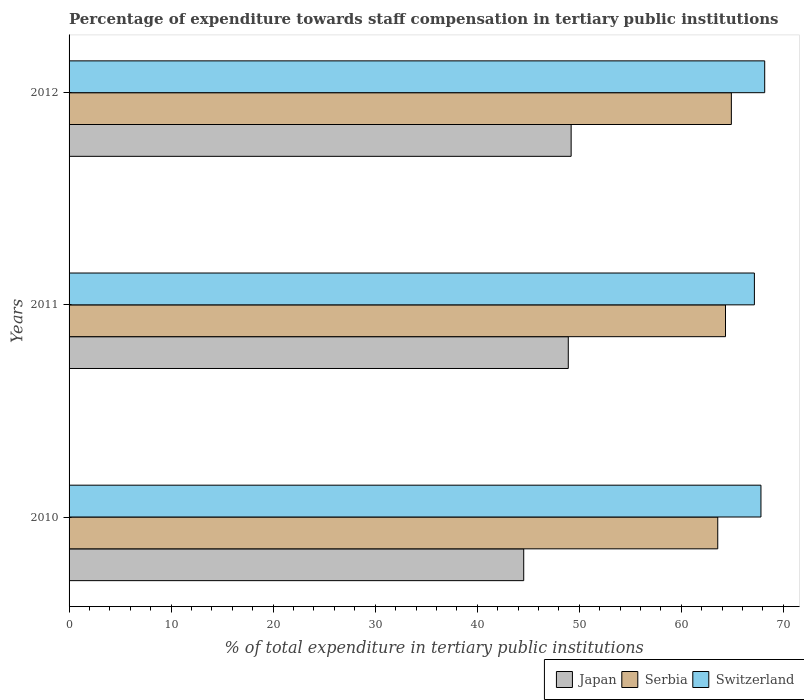Are the number of bars per tick equal to the number of legend labels?
Give a very brief answer. Yes. Are the number of bars on each tick of the Y-axis equal?
Make the answer very short. Yes. What is the percentage of expenditure towards staff compensation in Switzerland in 2012?
Ensure brevity in your answer.  68.18. Across all years, what is the maximum percentage of expenditure towards staff compensation in Serbia?
Keep it short and to the point. 64.91. Across all years, what is the minimum percentage of expenditure towards staff compensation in Switzerland?
Your answer should be compact. 67.16. In which year was the percentage of expenditure towards staff compensation in Switzerland maximum?
Give a very brief answer. 2012. What is the total percentage of expenditure towards staff compensation in Switzerland in the graph?
Give a very brief answer. 203.15. What is the difference between the percentage of expenditure towards staff compensation in Switzerland in 2010 and that in 2012?
Provide a succinct answer. -0.37. What is the difference between the percentage of expenditure towards staff compensation in Japan in 2010 and the percentage of expenditure towards staff compensation in Switzerland in 2012?
Ensure brevity in your answer.  -23.62. What is the average percentage of expenditure towards staff compensation in Serbia per year?
Offer a terse response. 64.27. In the year 2010, what is the difference between the percentage of expenditure towards staff compensation in Japan and percentage of expenditure towards staff compensation in Serbia?
Ensure brevity in your answer.  -19.02. What is the ratio of the percentage of expenditure towards staff compensation in Serbia in 2010 to that in 2011?
Give a very brief answer. 0.99. Is the difference between the percentage of expenditure towards staff compensation in Japan in 2011 and 2012 greater than the difference between the percentage of expenditure towards staff compensation in Serbia in 2011 and 2012?
Make the answer very short. Yes. What is the difference between the highest and the second highest percentage of expenditure towards staff compensation in Japan?
Make the answer very short. 0.28. What is the difference between the highest and the lowest percentage of expenditure towards staff compensation in Japan?
Provide a short and direct response. 4.65. In how many years, is the percentage of expenditure towards staff compensation in Serbia greater than the average percentage of expenditure towards staff compensation in Serbia taken over all years?
Ensure brevity in your answer.  2. What does the 2nd bar from the top in 2010 represents?
Your answer should be very brief. Serbia. What does the 3rd bar from the bottom in 2012 represents?
Your answer should be very brief. Switzerland. Is it the case that in every year, the sum of the percentage of expenditure towards staff compensation in Serbia and percentage of expenditure towards staff compensation in Switzerland is greater than the percentage of expenditure towards staff compensation in Japan?
Give a very brief answer. Yes. How many years are there in the graph?
Make the answer very short. 3. Are the values on the major ticks of X-axis written in scientific E-notation?
Offer a very short reply. No. Does the graph contain any zero values?
Your answer should be very brief. No. Does the graph contain grids?
Offer a very short reply. No. Where does the legend appear in the graph?
Provide a short and direct response. Bottom right. What is the title of the graph?
Your answer should be very brief. Percentage of expenditure towards staff compensation in tertiary public institutions. What is the label or title of the X-axis?
Provide a short and direct response. % of total expenditure in tertiary public institutions. What is the label or title of the Y-axis?
Provide a short and direct response. Years. What is the % of total expenditure in tertiary public institutions of Japan in 2010?
Keep it short and to the point. 44.56. What is the % of total expenditure in tertiary public institutions in Serbia in 2010?
Provide a short and direct response. 63.57. What is the % of total expenditure in tertiary public institutions of Switzerland in 2010?
Keep it short and to the point. 67.81. What is the % of total expenditure in tertiary public institutions in Japan in 2011?
Provide a succinct answer. 48.92. What is the % of total expenditure in tertiary public institutions of Serbia in 2011?
Provide a short and direct response. 64.33. What is the % of total expenditure in tertiary public institutions in Switzerland in 2011?
Give a very brief answer. 67.16. What is the % of total expenditure in tertiary public institutions of Japan in 2012?
Provide a short and direct response. 49.21. What is the % of total expenditure in tertiary public institutions in Serbia in 2012?
Your answer should be very brief. 64.91. What is the % of total expenditure in tertiary public institutions of Switzerland in 2012?
Offer a terse response. 68.18. Across all years, what is the maximum % of total expenditure in tertiary public institutions of Japan?
Provide a succinct answer. 49.21. Across all years, what is the maximum % of total expenditure in tertiary public institutions of Serbia?
Offer a very short reply. 64.91. Across all years, what is the maximum % of total expenditure in tertiary public institutions in Switzerland?
Give a very brief answer. 68.18. Across all years, what is the minimum % of total expenditure in tertiary public institutions of Japan?
Your answer should be compact. 44.56. Across all years, what is the minimum % of total expenditure in tertiary public institutions of Serbia?
Offer a very short reply. 63.57. Across all years, what is the minimum % of total expenditure in tertiary public institutions of Switzerland?
Provide a succinct answer. 67.16. What is the total % of total expenditure in tertiary public institutions of Japan in the graph?
Offer a very short reply. 142.69. What is the total % of total expenditure in tertiary public institutions in Serbia in the graph?
Your answer should be very brief. 192.81. What is the total % of total expenditure in tertiary public institutions in Switzerland in the graph?
Ensure brevity in your answer.  203.15. What is the difference between the % of total expenditure in tertiary public institutions in Japan in 2010 and that in 2011?
Give a very brief answer. -4.37. What is the difference between the % of total expenditure in tertiary public institutions of Serbia in 2010 and that in 2011?
Provide a succinct answer. -0.76. What is the difference between the % of total expenditure in tertiary public institutions of Switzerland in 2010 and that in 2011?
Make the answer very short. 0.64. What is the difference between the % of total expenditure in tertiary public institutions in Japan in 2010 and that in 2012?
Keep it short and to the point. -4.65. What is the difference between the % of total expenditure in tertiary public institutions of Serbia in 2010 and that in 2012?
Offer a terse response. -1.33. What is the difference between the % of total expenditure in tertiary public institutions of Switzerland in 2010 and that in 2012?
Provide a succinct answer. -0.37. What is the difference between the % of total expenditure in tertiary public institutions of Japan in 2011 and that in 2012?
Your answer should be very brief. -0.28. What is the difference between the % of total expenditure in tertiary public institutions of Serbia in 2011 and that in 2012?
Your answer should be very brief. -0.57. What is the difference between the % of total expenditure in tertiary public institutions in Switzerland in 2011 and that in 2012?
Offer a terse response. -1.01. What is the difference between the % of total expenditure in tertiary public institutions of Japan in 2010 and the % of total expenditure in tertiary public institutions of Serbia in 2011?
Provide a short and direct response. -19.78. What is the difference between the % of total expenditure in tertiary public institutions of Japan in 2010 and the % of total expenditure in tertiary public institutions of Switzerland in 2011?
Give a very brief answer. -22.61. What is the difference between the % of total expenditure in tertiary public institutions in Serbia in 2010 and the % of total expenditure in tertiary public institutions in Switzerland in 2011?
Ensure brevity in your answer.  -3.59. What is the difference between the % of total expenditure in tertiary public institutions of Japan in 2010 and the % of total expenditure in tertiary public institutions of Serbia in 2012?
Offer a very short reply. -20.35. What is the difference between the % of total expenditure in tertiary public institutions in Japan in 2010 and the % of total expenditure in tertiary public institutions in Switzerland in 2012?
Your answer should be compact. -23.62. What is the difference between the % of total expenditure in tertiary public institutions in Serbia in 2010 and the % of total expenditure in tertiary public institutions in Switzerland in 2012?
Your answer should be compact. -4.6. What is the difference between the % of total expenditure in tertiary public institutions of Japan in 2011 and the % of total expenditure in tertiary public institutions of Serbia in 2012?
Make the answer very short. -15.98. What is the difference between the % of total expenditure in tertiary public institutions of Japan in 2011 and the % of total expenditure in tertiary public institutions of Switzerland in 2012?
Make the answer very short. -19.25. What is the difference between the % of total expenditure in tertiary public institutions in Serbia in 2011 and the % of total expenditure in tertiary public institutions in Switzerland in 2012?
Offer a very short reply. -3.84. What is the average % of total expenditure in tertiary public institutions in Japan per year?
Provide a succinct answer. 47.56. What is the average % of total expenditure in tertiary public institutions of Serbia per year?
Provide a short and direct response. 64.27. What is the average % of total expenditure in tertiary public institutions of Switzerland per year?
Keep it short and to the point. 67.72. In the year 2010, what is the difference between the % of total expenditure in tertiary public institutions in Japan and % of total expenditure in tertiary public institutions in Serbia?
Offer a very short reply. -19.02. In the year 2010, what is the difference between the % of total expenditure in tertiary public institutions of Japan and % of total expenditure in tertiary public institutions of Switzerland?
Keep it short and to the point. -23.25. In the year 2010, what is the difference between the % of total expenditure in tertiary public institutions of Serbia and % of total expenditure in tertiary public institutions of Switzerland?
Your answer should be very brief. -4.23. In the year 2011, what is the difference between the % of total expenditure in tertiary public institutions of Japan and % of total expenditure in tertiary public institutions of Serbia?
Give a very brief answer. -15.41. In the year 2011, what is the difference between the % of total expenditure in tertiary public institutions in Japan and % of total expenditure in tertiary public institutions in Switzerland?
Ensure brevity in your answer.  -18.24. In the year 2011, what is the difference between the % of total expenditure in tertiary public institutions in Serbia and % of total expenditure in tertiary public institutions in Switzerland?
Make the answer very short. -2.83. In the year 2012, what is the difference between the % of total expenditure in tertiary public institutions of Japan and % of total expenditure in tertiary public institutions of Serbia?
Your answer should be compact. -15.7. In the year 2012, what is the difference between the % of total expenditure in tertiary public institutions of Japan and % of total expenditure in tertiary public institutions of Switzerland?
Make the answer very short. -18.97. In the year 2012, what is the difference between the % of total expenditure in tertiary public institutions in Serbia and % of total expenditure in tertiary public institutions in Switzerland?
Keep it short and to the point. -3.27. What is the ratio of the % of total expenditure in tertiary public institutions of Japan in 2010 to that in 2011?
Your answer should be very brief. 0.91. What is the ratio of the % of total expenditure in tertiary public institutions of Switzerland in 2010 to that in 2011?
Offer a very short reply. 1.01. What is the ratio of the % of total expenditure in tertiary public institutions in Japan in 2010 to that in 2012?
Provide a succinct answer. 0.91. What is the ratio of the % of total expenditure in tertiary public institutions in Serbia in 2010 to that in 2012?
Your answer should be compact. 0.98. What is the ratio of the % of total expenditure in tertiary public institutions in Switzerland in 2010 to that in 2012?
Ensure brevity in your answer.  0.99. What is the ratio of the % of total expenditure in tertiary public institutions of Japan in 2011 to that in 2012?
Provide a short and direct response. 0.99. What is the ratio of the % of total expenditure in tertiary public institutions of Switzerland in 2011 to that in 2012?
Offer a very short reply. 0.99. What is the difference between the highest and the second highest % of total expenditure in tertiary public institutions in Japan?
Provide a short and direct response. 0.28. What is the difference between the highest and the second highest % of total expenditure in tertiary public institutions of Serbia?
Make the answer very short. 0.57. What is the difference between the highest and the second highest % of total expenditure in tertiary public institutions in Switzerland?
Provide a short and direct response. 0.37. What is the difference between the highest and the lowest % of total expenditure in tertiary public institutions of Japan?
Your response must be concise. 4.65. What is the difference between the highest and the lowest % of total expenditure in tertiary public institutions of Serbia?
Offer a very short reply. 1.33. What is the difference between the highest and the lowest % of total expenditure in tertiary public institutions in Switzerland?
Offer a terse response. 1.01. 